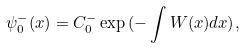Convert formula to latex. <formula><loc_0><loc_0><loc_500><loc_500>\psi ^ { - } _ { 0 } ( x ) = C _ { 0 } ^ { - } \exp { ( - \int W ( x ) d x ) } ,</formula> 